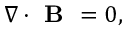<formula> <loc_0><loc_0><loc_500><loc_500>\begin{array} { r } { \nabla \cdot B = 0 , } \end{array}</formula> 